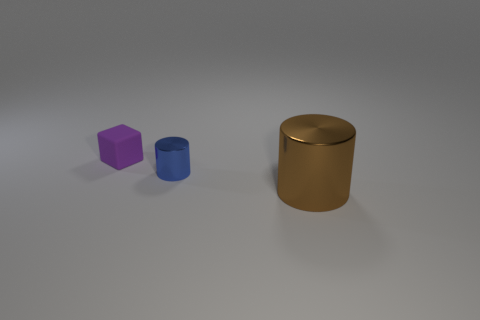Are there any matte cubes of the same size as the purple matte thing? no 